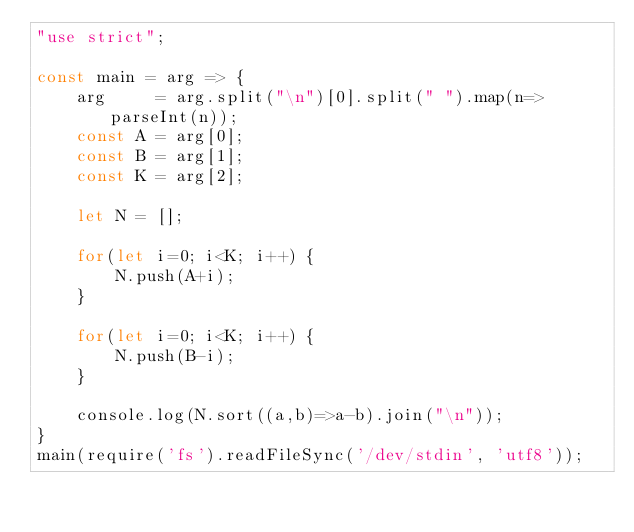<code> <loc_0><loc_0><loc_500><loc_500><_JavaScript_>"use strict";
    
const main = arg => {
    arg     = arg.split("\n")[0].split(" ").map(n=>parseInt(n));
    const A = arg[0];
    const B = arg[1];
    const K = arg[2];
    
    let N = [];
    
    for(let i=0; i<K; i++) {
        N.push(A+i);
    }
    
    for(let i=0; i<K; i++) {
        N.push(B-i);
    }
    
    console.log(N.sort((a,b)=>a-b).join("\n"));
}
main(require('fs').readFileSync('/dev/stdin', 'utf8'));</code> 